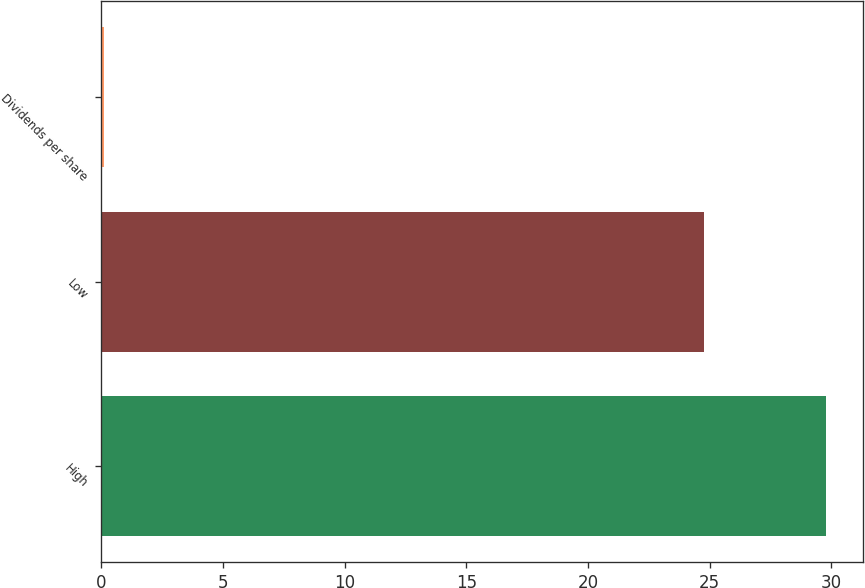Convert chart to OTSL. <chart><loc_0><loc_0><loc_500><loc_500><bar_chart><fcel>High<fcel>Low<fcel>Dividends per share<nl><fcel>29.79<fcel>24.77<fcel>0.1<nl></chart> 